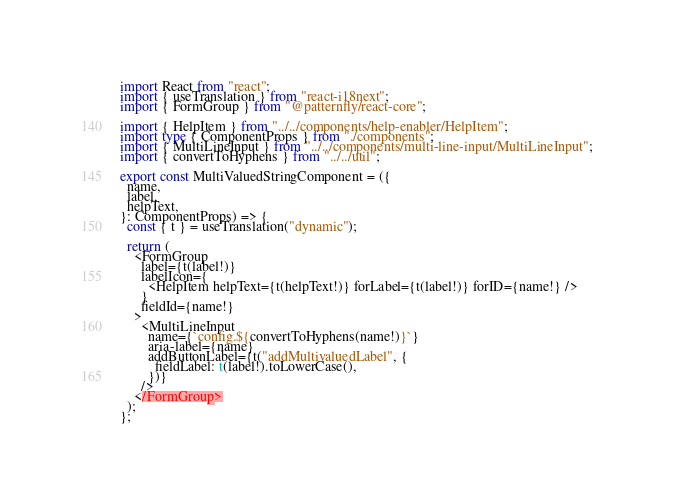Convert code to text. <code><loc_0><loc_0><loc_500><loc_500><_TypeScript_>import React from "react";
import { useTranslation } from "react-i18next";
import { FormGroup } from "@patternfly/react-core";

import { HelpItem } from "../../components/help-enabler/HelpItem";
import type { ComponentProps } from "./components";
import { MultiLineInput } from "../../components/multi-line-input/MultiLineInput";
import { convertToHyphens } from "../../util";

export const MultiValuedStringComponent = ({
  name,
  label,
  helpText,
}: ComponentProps) => {
  const { t } = useTranslation("dynamic");

  return (
    <FormGroup
      label={t(label!)}
      labelIcon={
        <HelpItem helpText={t(helpText!)} forLabel={t(label!)} forID={name!} />
      }
      fieldId={name!}
    >
      <MultiLineInput
        name={`config.${convertToHyphens(name!)}`}
        aria-label={name}
        addButtonLabel={t("addMultivaluedLabel", {
          fieldLabel: t(label!).toLowerCase(),
        })}
      />
    </FormGroup>
  );
};
</code> 